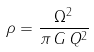Convert formula to latex. <formula><loc_0><loc_0><loc_500><loc_500>\rho = \frac { \Omega ^ { 2 } } { \pi \, G \, Q ^ { 2 } }</formula> 